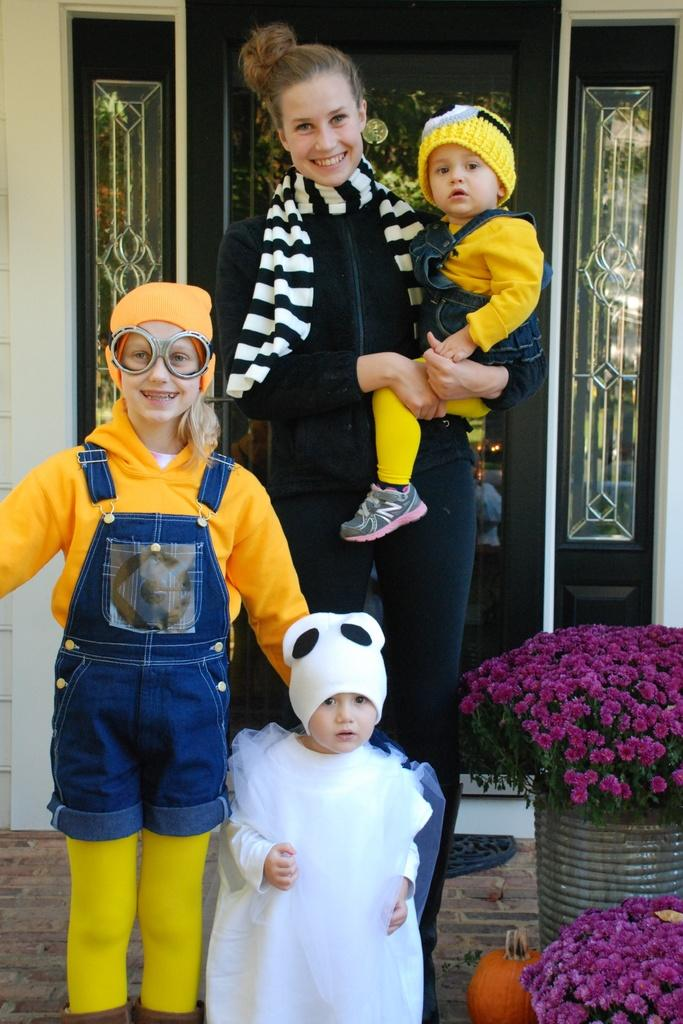Who is present in the image? There is a woman in the image. What is the woman doing in the image? The woman is holding a kid. How many kids are visible in the image? There are two kids standing in the image. What type of vegetation can be seen in the image? There are flowers in the image. What architectural feature is visible in the background of the image? There is a door visible in the background of the image. What type of berry is the woman using to apply sunscreen on the kids' skin in the image? There is no berry or sunscreen present in the image; the woman is simply holding a kid. What type of shake is the woman making for the kids in the image? There is no shake-making activity depicted in the image. 